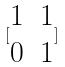Convert formula to latex. <formula><loc_0><loc_0><loc_500><loc_500>[ \begin{matrix} 1 & 1 \\ 0 & 1 \end{matrix} ]</formula> 